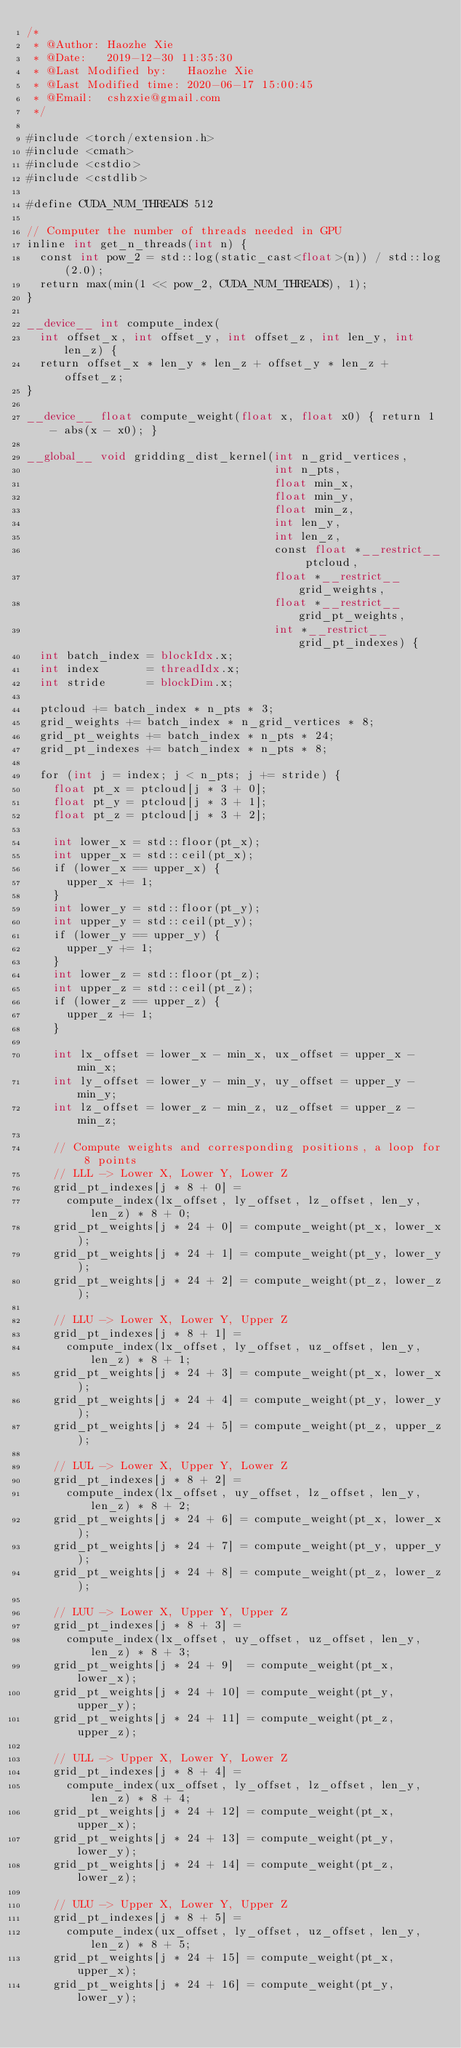Convert code to text. <code><loc_0><loc_0><loc_500><loc_500><_Cuda_>/*
 * @Author: Haozhe Xie
 * @Date:   2019-12-30 11:35:30
 * @Last Modified by:   Haozhe Xie
 * @Last Modified time: 2020-06-17 15:00:45
 * @Email:  cshzxie@gmail.com
 */

#include <torch/extension.h>
#include <cmath>
#include <cstdio>
#include <cstdlib>

#define CUDA_NUM_THREADS 512

// Computer the number of threads needed in GPU
inline int get_n_threads(int n) {
  const int pow_2 = std::log(static_cast<float>(n)) / std::log(2.0);
  return max(min(1 << pow_2, CUDA_NUM_THREADS), 1);
}

__device__ int compute_index(
  int offset_x, int offset_y, int offset_z, int len_y, int len_z) {
  return offset_x * len_y * len_z + offset_y * len_z + offset_z;
}

__device__ float compute_weight(float x, float x0) { return 1 - abs(x - x0); }

__global__ void gridding_dist_kernel(int n_grid_vertices,
                                     int n_pts,
                                     float min_x,
                                     float min_y,
                                     float min_z,
                                     int len_y,
                                     int len_z,
                                     const float *__restrict__ ptcloud,
                                     float *__restrict__ grid_weights,
                                     float *__restrict__ grid_pt_weights,
                                     int *__restrict__ grid_pt_indexes) {
  int batch_index = blockIdx.x;
  int index       = threadIdx.x;
  int stride      = blockDim.x;

  ptcloud += batch_index * n_pts * 3;
  grid_weights += batch_index * n_grid_vertices * 8;
  grid_pt_weights += batch_index * n_pts * 24;
  grid_pt_indexes += batch_index * n_pts * 8;

  for (int j = index; j < n_pts; j += stride) {
    float pt_x = ptcloud[j * 3 + 0];
    float pt_y = ptcloud[j * 3 + 1];
    float pt_z = ptcloud[j * 3 + 2];

    int lower_x = std::floor(pt_x);
    int upper_x = std::ceil(pt_x);
    if (lower_x == upper_x) {
      upper_x += 1;
    }
    int lower_y = std::floor(pt_y);
    int upper_y = std::ceil(pt_y);
    if (lower_y == upper_y) {
      upper_y += 1;
    }
    int lower_z = std::floor(pt_z);
    int upper_z = std::ceil(pt_z);
    if (lower_z == upper_z) {
      upper_z += 1;
    }

    int lx_offset = lower_x - min_x, ux_offset = upper_x - min_x;
    int ly_offset = lower_y - min_y, uy_offset = upper_y - min_y;
    int lz_offset = lower_z - min_z, uz_offset = upper_z - min_z;

    // Compute weights and corresponding positions, a loop for 8 points
    // LLL -> Lower X, Lower Y, Lower Z
    grid_pt_indexes[j * 8 + 0] =
      compute_index(lx_offset, ly_offset, lz_offset, len_y, len_z) * 8 + 0;
    grid_pt_weights[j * 24 + 0] = compute_weight(pt_x, lower_x);
    grid_pt_weights[j * 24 + 1] = compute_weight(pt_y, lower_y);
    grid_pt_weights[j * 24 + 2] = compute_weight(pt_z, lower_z);

    // LLU -> Lower X, Lower Y, Upper Z
    grid_pt_indexes[j * 8 + 1] =
      compute_index(lx_offset, ly_offset, uz_offset, len_y, len_z) * 8 + 1;
    grid_pt_weights[j * 24 + 3] = compute_weight(pt_x, lower_x);
    grid_pt_weights[j * 24 + 4] = compute_weight(pt_y, lower_y);
    grid_pt_weights[j * 24 + 5] = compute_weight(pt_z, upper_z);

    // LUL -> Lower X, Upper Y, Lower Z
    grid_pt_indexes[j * 8 + 2] =
      compute_index(lx_offset, uy_offset, lz_offset, len_y, len_z) * 8 + 2;
    grid_pt_weights[j * 24 + 6] = compute_weight(pt_x, lower_x);
    grid_pt_weights[j * 24 + 7] = compute_weight(pt_y, upper_y);
    grid_pt_weights[j * 24 + 8] = compute_weight(pt_z, lower_z);

    // LUU -> Lower X, Upper Y, Upper Z
    grid_pt_indexes[j * 8 + 3] =
      compute_index(lx_offset, uy_offset, uz_offset, len_y, len_z) * 8 + 3;
    grid_pt_weights[j * 24 + 9]  = compute_weight(pt_x, lower_x);
    grid_pt_weights[j * 24 + 10] = compute_weight(pt_y, upper_y);
    grid_pt_weights[j * 24 + 11] = compute_weight(pt_z, upper_z);

    // ULL -> Upper X, Lower Y, Lower Z
    grid_pt_indexes[j * 8 + 4] =
      compute_index(ux_offset, ly_offset, lz_offset, len_y, len_z) * 8 + 4;
    grid_pt_weights[j * 24 + 12] = compute_weight(pt_x, upper_x);
    grid_pt_weights[j * 24 + 13] = compute_weight(pt_y, lower_y);
    grid_pt_weights[j * 24 + 14] = compute_weight(pt_z, lower_z);

    // ULU -> Upper X, Lower Y, Upper Z
    grid_pt_indexes[j * 8 + 5] =
      compute_index(ux_offset, ly_offset, uz_offset, len_y, len_z) * 8 + 5;
    grid_pt_weights[j * 24 + 15] = compute_weight(pt_x, upper_x);
    grid_pt_weights[j * 24 + 16] = compute_weight(pt_y, lower_y);</code> 